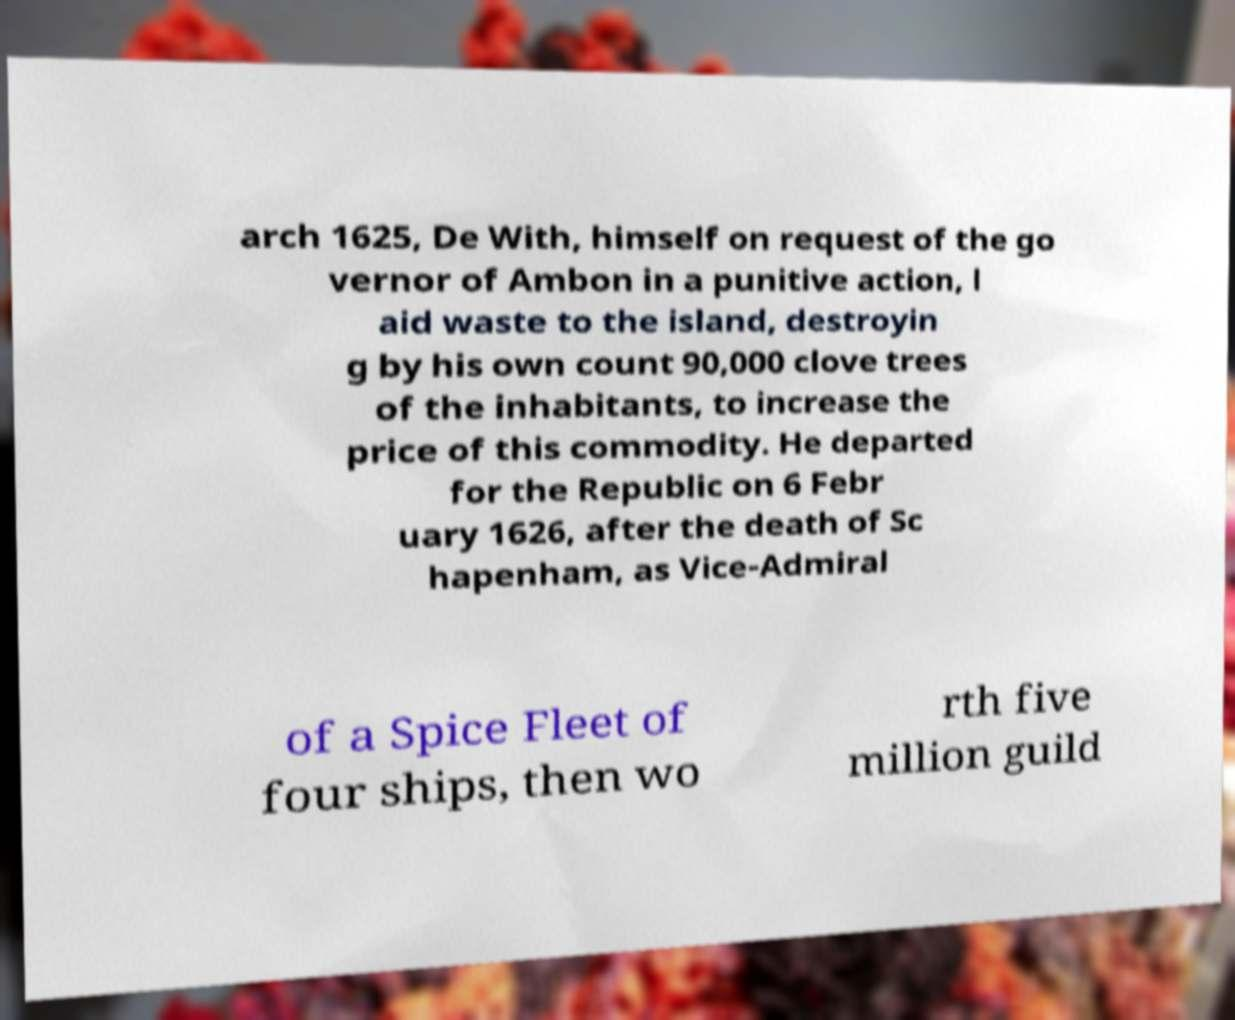Please read and relay the text visible in this image. What does it say? arch 1625, De With, himself on request of the go vernor of Ambon in a punitive action, l aid waste to the island, destroyin g by his own count 90,000 clove trees of the inhabitants, to increase the price of this commodity. He departed for the Republic on 6 Febr uary 1626, after the death of Sc hapenham, as Vice-Admiral of a Spice Fleet of four ships, then wo rth five million guild 